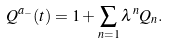Convert formula to latex. <formula><loc_0><loc_0><loc_500><loc_500>Q ^ { a _ { - } } ( t ) = 1 + \sum _ { n = 1 } \lambda ^ { n } Q _ { n } .</formula> 